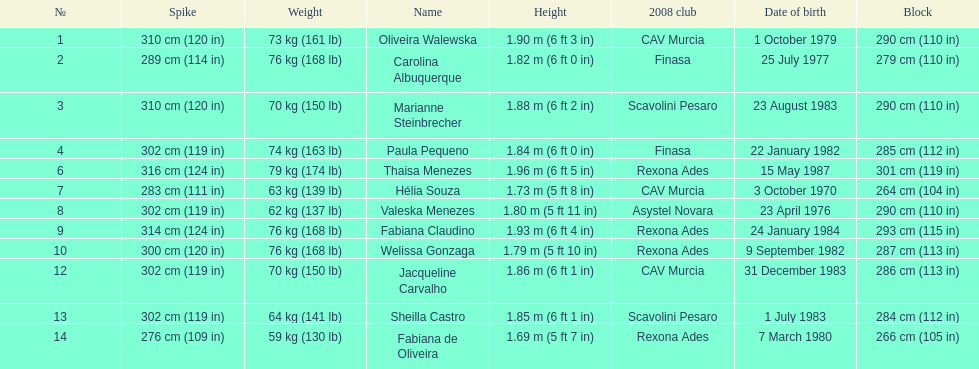Which player is the shortest at only 5 ft 7 in? Fabiana de Oliveira. 